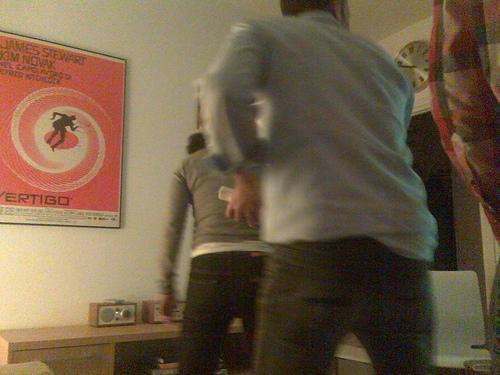How many people are there?
Give a very brief answer. 2. How many people are in the photo?
Give a very brief answer. 3. 